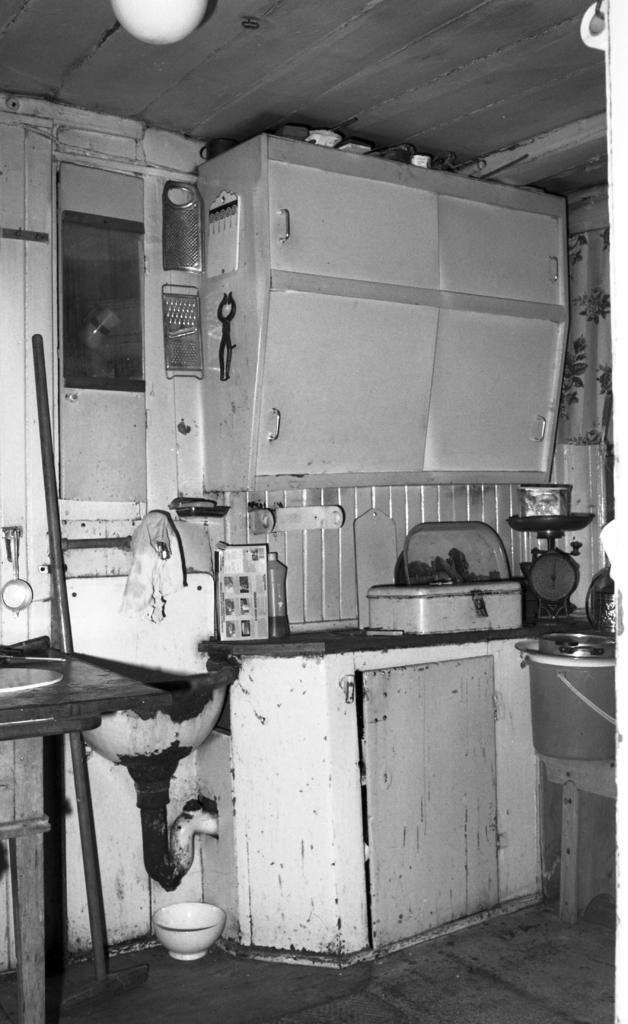Can you describe this image briefly? I see this is a black and white image and I see a cupboard over here and I see many things over here and I see the weighing machine over here and I see the ceiling and I see the floor. 